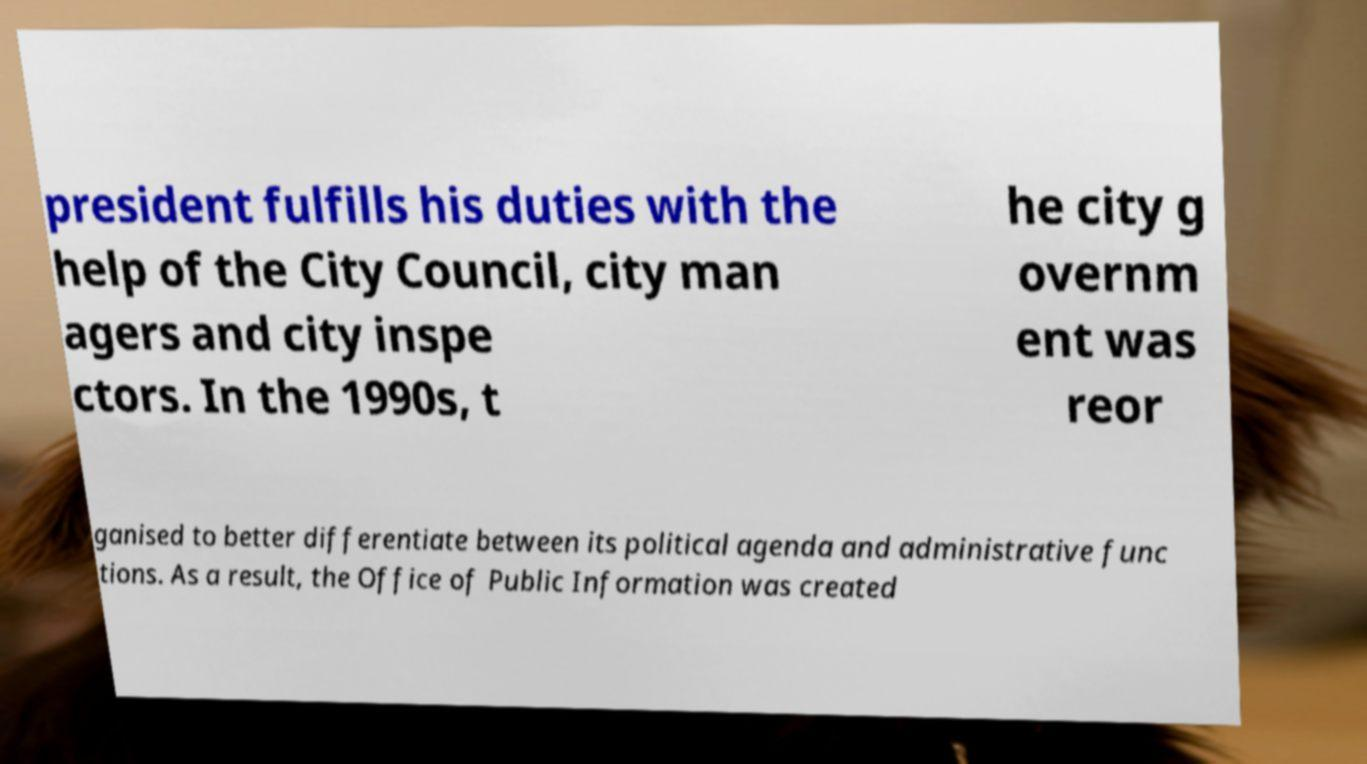What messages or text are displayed in this image? I need them in a readable, typed format. president fulfills his duties with the help of the City Council, city man agers and city inspe ctors. In the 1990s, t he city g overnm ent was reor ganised to better differentiate between its political agenda and administrative func tions. As a result, the Office of Public Information was created 